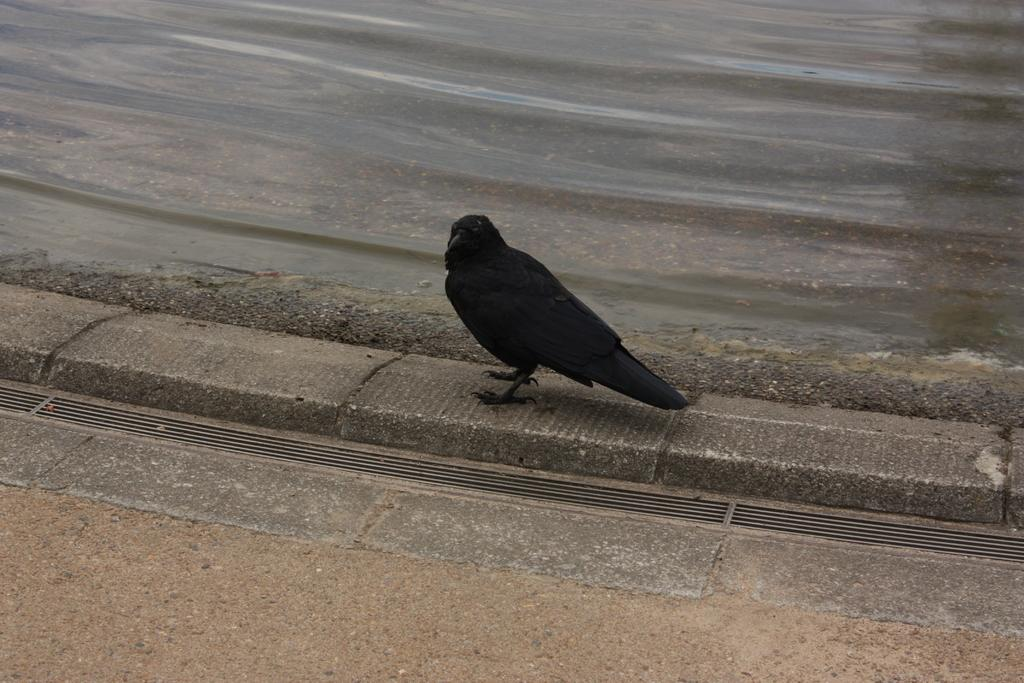What type of bird is in the image? There is a black crow in the image. Where is the crow located in the image? The crow is on the ground. What else can be seen in the image besides the crow? There is water visible in the image. What type of vegetable is being discussed in the story in the image? There is no story or vegetable present in the image; it features a black crow on the ground and water. 